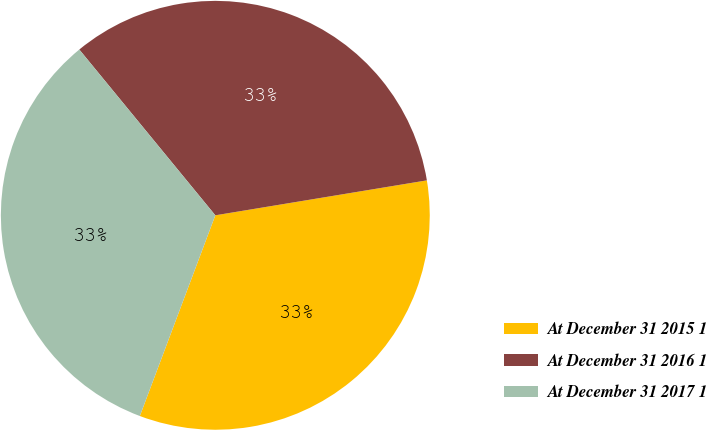Convert chart. <chart><loc_0><loc_0><loc_500><loc_500><pie_chart><fcel>At December 31 2015 1<fcel>At December 31 2016 1<fcel>At December 31 2017 1<nl><fcel>33.33%<fcel>33.33%<fcel>33.34%<nl></chart> 